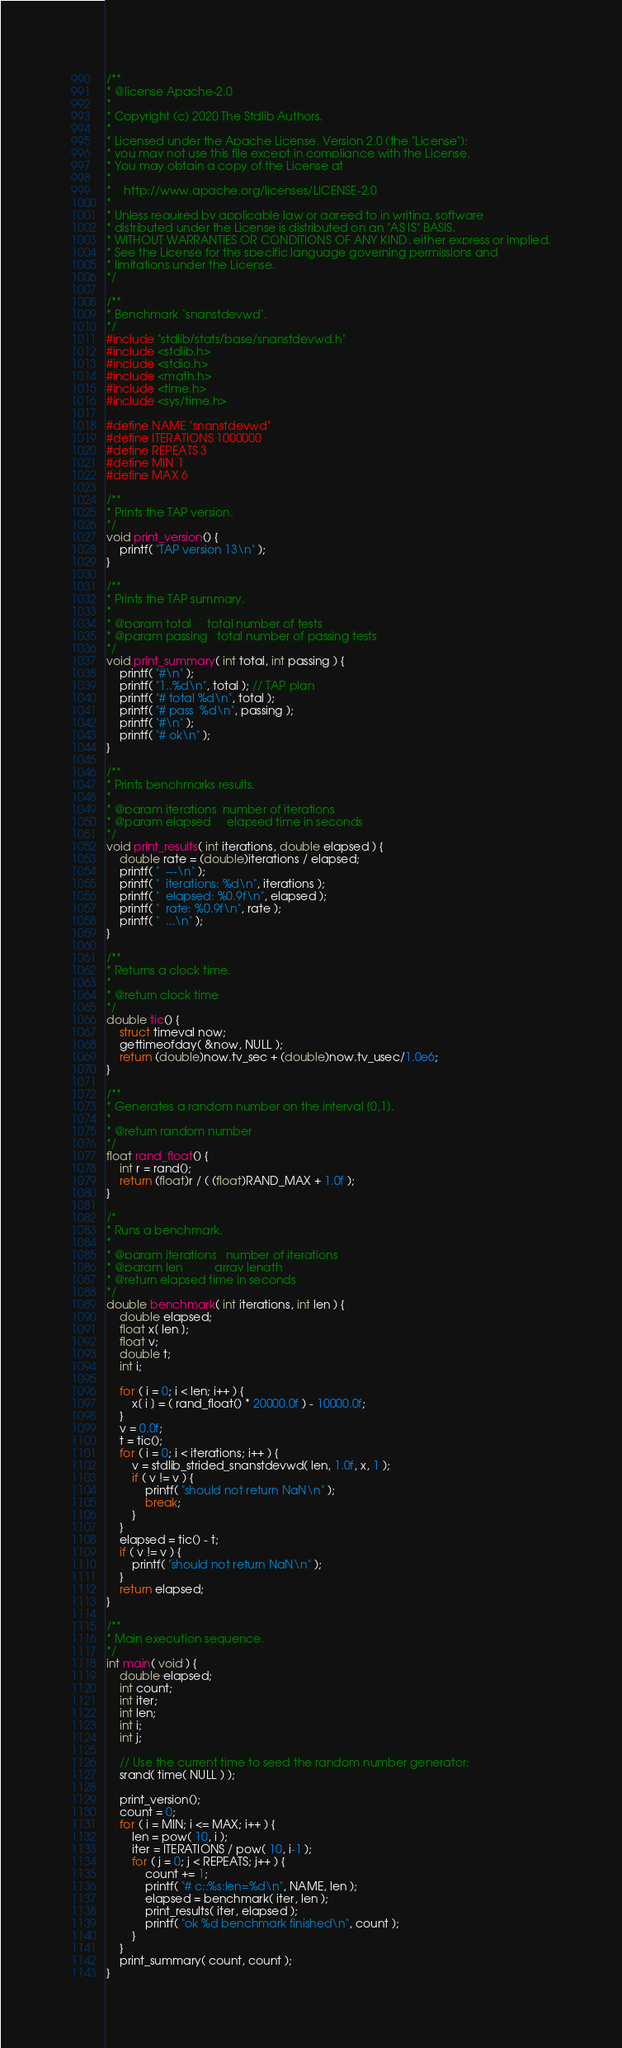Convert code to text. <code><loc_0><loc_0><loc_500><loc_500><_C_>/**
* @license Apache-2.0
*
* Copyright (c) 2020 The Stdlib Authors.
*
* Licensed under the Apache License, Version 2.0 (the "License");
* you may not use this file except in compliance with the License.
* You may obtain a copy of the License at
*
*    http://www.apache.org/licenses/LICENSE-2.0
*
* Unless required by applicable law or agreed to in writing, software
* distributed under the License is distributed on an "AS IS" BASIS,
* WITHOUT WARRANTIES OR CONDITIONS OF ANY KIND, either express or implied.
* See the License for the specific language governing permissions and
* limitations under the License.
*/

/**
* Benchmark `snanstdevwd`.
*/
#include "stdlib/stats/base/snanstdevwd.h"
#include <stdlib.h>
#include <stdio.h>
#include <math.h>
#include <time.h>
#include <sys/time.h>

#define NAME "snanstdevwd"
#define ITERATIONS 1000000
#define REPEATS 3
#define MIN 1
#define MAX 6

/**
* Prints the TAP version.
*/
void print_version() {
	printf( "TAP version 13\n" );
}

/**
* Prints the TAP summary.
*
* @param total     total number of tests
* @param passing   total number of passing tests
*/
void print_summary( int total, int passing ) {
	printf( "#\n" );
	printf( "1..%d\n", total ); // TAP plan
	printf( "# total %d\n", total );
	printf( "# pass  %d\n", passing );
	printf( "#\n" );
	printf( "# ok\n" );
}

/**
* Prints benchmarks results.
*
* @param iterations  number of iterations
* @param elapsed     elapsed time in seconds
*/
void print_results( int iterations, double elapsed ) {
	double rate = (double)iterations / elapsed;
	printf( "  ---\n" );
	printf( "  iterations: %d\n", iterations );
	printf( "  elapsed: %0.9f\n", elapsed );
	printf( "  rate: %0.9f\n", rate );
	printf( "  ...\n" );
}

/**
* Returns a clock time.
*
* @return clock time
*/
double tic() {
	struct timeval now;
	gettimeofday( &now, NULL );
	return (double)now.tv_sec + (double)now.tv_usec/1.0e6;
}

/**
* Generates a random number on the interval [0,1].
*
* @return random number
*/
float rand_float() {
	int r = rand();
	return (float)r / ( (float)RAND_MAX + 1.0f );
}

/*
* Runs a benchmark.
*
* @param iterations   number of iterations
* @param len          array length
* @return elapsed time in seconds
*/
double benchmark( int iterations, int len ) {
	double elapsed;
	float x[ len ];
	float v;
	double t;
	int i;

	for ( i = 0; i < len; i++ ) {
		x[ i ] = ( rand_float() * 20000.0f ) - 10000.0f;
	}
	v = 0.0f;
	t = tic();
	for ( i = 0; i < iterations; i++ ) {
		v = stdlib_strided_snanstdevwd( len, 1.0f, x, 1 );
		if ( v != v ) {
			printf( "should not return NaN\n" );
			break;
		}
	}
	elapsed = tic() - t;
	if ( v != v ) {
		printf( "should not return NaN\n" );
	}
	return elapsed;
}

/**
* Main execution sequence.
*/
int main( void ) {
	double elapsed;
	int count;
	int iter;
	int len;
	int i;
	int j;

	// Use the current time to seed the random number generator:
	srand( time( NULL ) );

	print_version();
	count = 0;
	for ( i = MIN; i <= MAX; i++ ) {
		len = pow( 10, i );
		iter = ITERATIONS / pow( 10, i-1 );
		for ( j = 0; j < REPEATS; j++ ) {
			count += 1;
			printf( "# c::%s:len=%d\n", NAME, len );
			elapsed = benchmark( iter, len );
			print_results( iter, elapsed );
			printf( "ok %d benchmark finished\n", count );
		}
	}
	print_summary( count, count );
}
</code> 